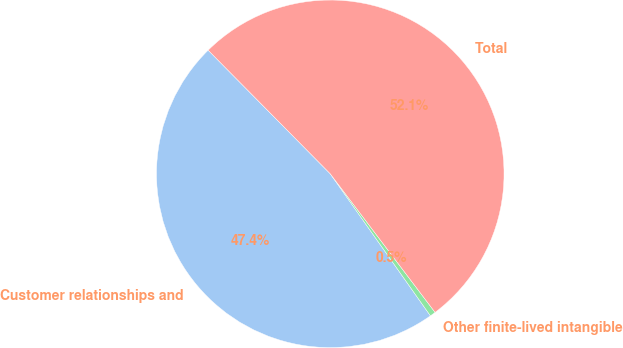<chart> <loc_0><loc_0><loc_500><loc_500><pie_chart><fcel>Customer relationships and<fcel>Other finite-lived intangible<fcel>Total<nl><fcel>47.37%<fcel>0.53%<fcel>52.1%<nl></chart> 